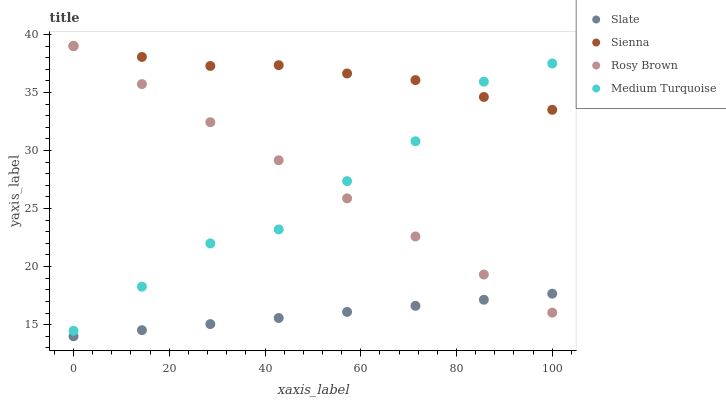Does Slate have the minimum area under the curve?
Answer yes or no. Yes. Does Sienna have the maximum area under the curve?
Answer yes or no. Yes. Does Rosy Brown have the minimum area under the curve?
Answer yes or no. No. Does Rosy Brown have the maximum area under the curve?
Answer yes or no. No. Is Rosy Brown the smoothest?
Answer yes or no. Yes. Is Medium Turquoise the roughest?
Answer yes or no. Yes. Is Slate the smoothest?
Answer yes or no. No. Is Slate the roughest?
Answer yes or no. No. Does Slate have the lowest value?
Answer yes or no. Yes. Does Rosy Brown have the lowest value?
Answer yes or no. No. Does Rosy Brown have the highest value?
Answer yes or no. Yes. Does Slate have the highest value?
Answer yes or no. No. Is Slate less than Medium Turquoise?
Answer yes or no. Yes. Is Medium Turquoise greater than Slate?
Answer yes or no. Yes. Does Medium Turquoise intersect Rosy Brown?
Answer yes or no. Yes. Is Medium Turquoise less than Rosy Brown?
Answer yes or no. No. Is Medium Turquoise greater than Rosy Brown?
Answer yes or no. No. Does Slate intersect Medium Turquoise?
Answer yes or no. No. 